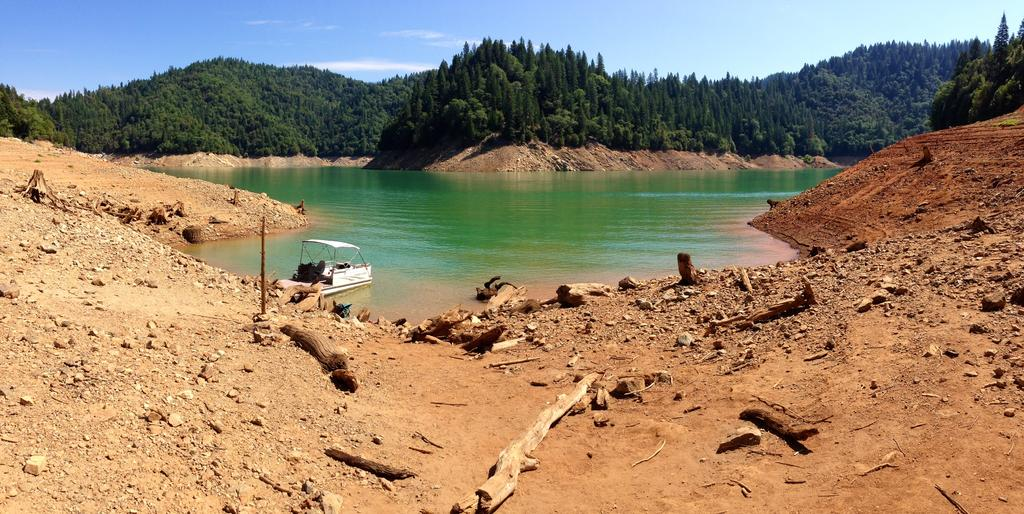What type of terrain is depicted in the image? There is mud in the image. What objects can be seen in the mud? There are wooden sticks and stones in the image. What is located in the water in the image? There is a boat in the water in the image. What can be seen in the background of the image? There are trees and the sky visible in the background of the image. What type of thing is being held in jail in the image? There is no jail or thing being held in jail present in the image. What act is being performed by the trees in the background of the image? The trees are not performing any act; they are simply standing in the background of the image. 